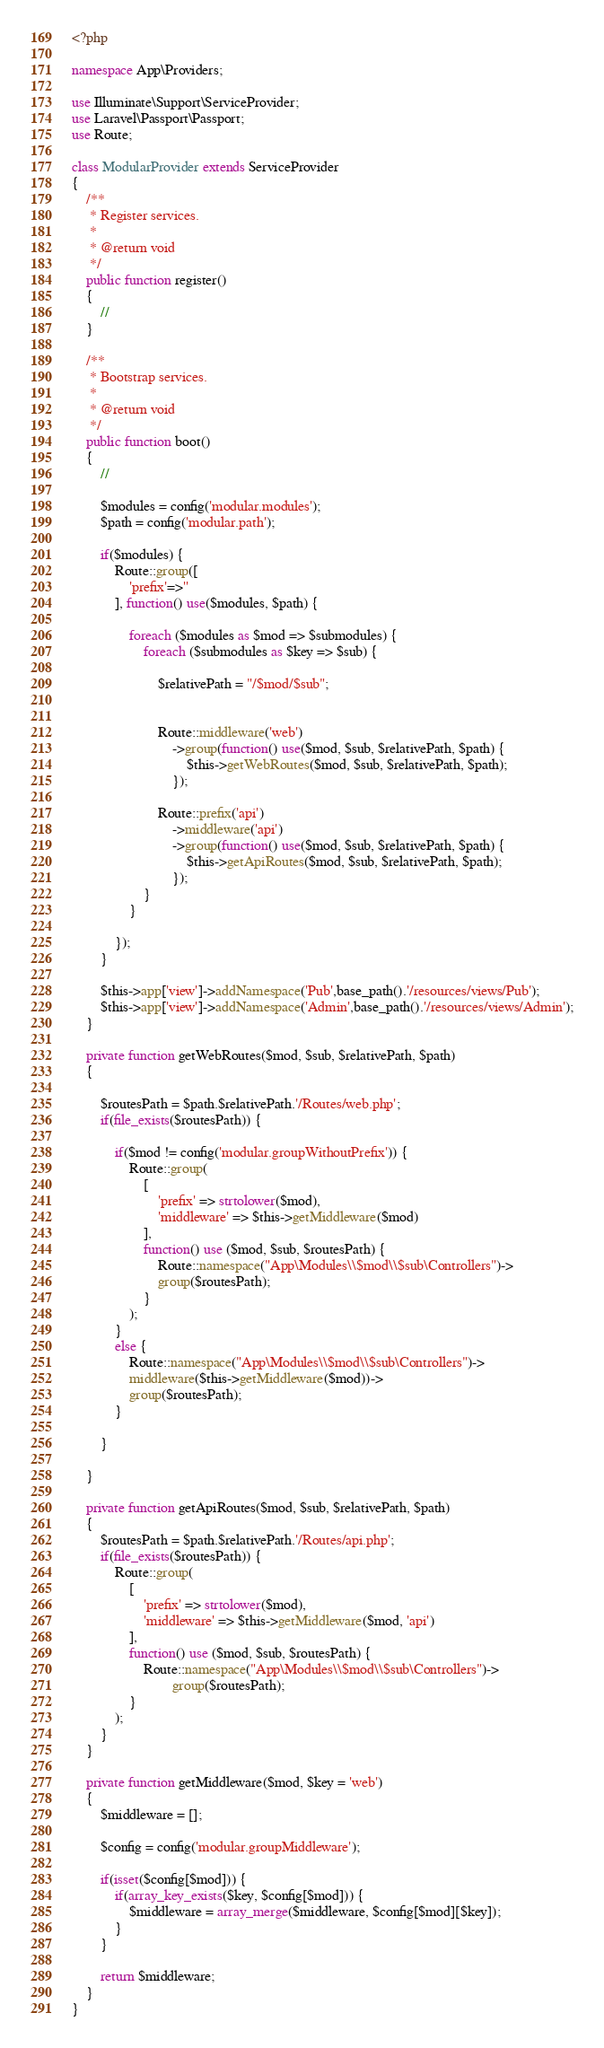<code> <loc_0><loc_0><loc_500><loc_500><_PHP_><?php

namespace App\Providers;

use Illuminate\Support\ServiceProvider;
use Laravel\Passport\Passport;
use Route;

class ModularProvider extends ServiceProvider
{
    /**
     * Register services.
     *
     * @return void
     */
    public function register()
    {
        //
    }

    /**
     * Bootstrap services.
     *
     * @return void
     */
    public function boot()
    {
        //

        $modules = config('modular.modules');
        $path = config('modular.path');

        if($modules) {
            Route::group([
                'prefix'=>''
            ], function() use($modules, $path) {

                foreach ($modules as $mod => $submodules) {
                    foreach ($submodules as $key => $sub) {

                        $relativePath = "/$mod/$sub";


                        Route::middleware('web')
                            ->group(function() use($mod, $sub, $relativePath, $path) {
                                $this->getWebRoutes($mod, $sub, $relativePath, $path);
                            });

                        Route::prefix('api')
                            ->middleware('api')
                            ->group(function() use($mod, $sub, $relativePath, $path) {
                                $this->getApiRoutes($mod, $sub, $relativePath, $path);
                            });
                    }
                }

            });
        }

        $this->app['view']->addNamespace('Pub',base_path().'/resources/views/Pub');
        $this->app['view']->addNamespace('Admin',base_path().'/resources/views/Admin');
    }

    private function getWebRoutes($mod, $sub, $relativePath, $path)
    {

        $routesPath = $path.$relativePath.'/Routes/web.php';
        if(file_exists($routesPath)) {

            if($mod != config('modular.groupWithoutPrefix')) {
                Route::group(
                    [
                        'prefix' => strtolower($mod),
                        'middleware' => $this->getMiddleware($mod)
                    ],
                    function() use ($mod, $sub, $routesPath) {
                        Route::namespace("App\Modules\\$mod\\$sub\Controllers")->
                        group($routesPath);
                    }
                );
            }
            else {
                Route::namespace("App\Modules\\$mod\\$sub\Controllers")->
                middleware($this->getMiddleware($mod))->
                group($routesPath);
            }

        }

    }

    private function getApiRoutes($mod, $sub, $relativePath, $path)
    {
        $routesPath = $path.$relativePath.'/Routes/api.php';
        if(file_exists($routesPath)) {
            Route::group(
                [
                    'prefix' => strtolower($mod),
                    'middleware' => $this->getMiddleware($mod, 'api')
                ],
                function() use ($mod, $sub, $routesPath) {
                    Route::namespace("App\Modules\\$mod\\$sub\Controllers")->
                            group($routesPath);
                }
            );
        }
    }

    private function getMiddleware($mod, $key = 'web')
    {
        $middleware = [];

        $config = config('modular.groupMiddleware');

        if(isset($config[$mod])) {
            if(array_key_exists($key, $config[$mod])) {
                $middleware = array_merge($middleware, $config[$mod][$key]);
            }
        }

        return $middleware;
    }
}
</code> 